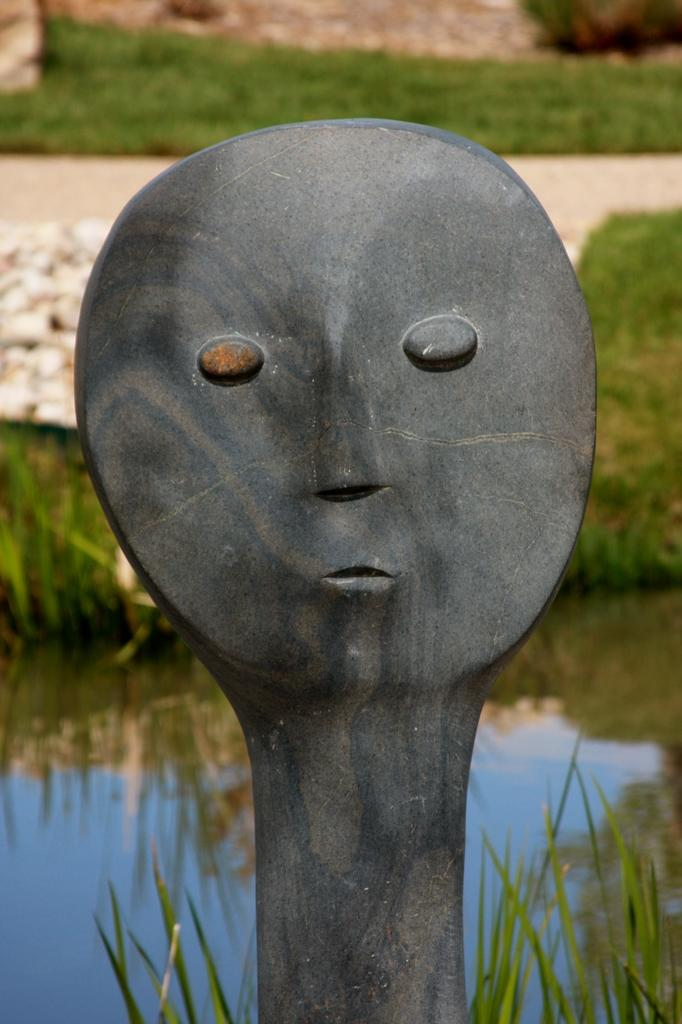What type of sculpture can be seen in the image? There is a rock sculpture in the image. What natural element is present in the image? Water is visible in the image. What type of vegetation is in the image? There is grass in the image. What other objects are present in the image? There are stones in the image. How would you describe the background of the image? The background of the image is slightly blurred. Can you see anyone kicking a rail in the image? There is no rail or anyone kicking it present in the image. 